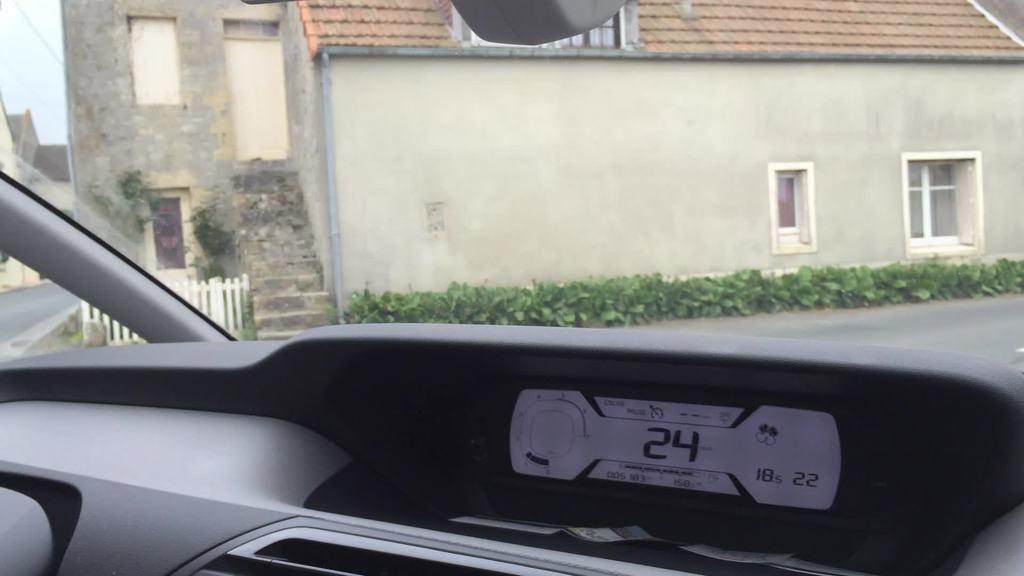Could you give a brief overview of what you see in this image? In this image, we can see the inside view of a vehicle. Here we can see digital screen, glass objects and few things. Through the glass we can see the outside view. Here we can see few houses, stairs, plants, wall, windows, door and road. On the left side of the image, we can see fencing. 